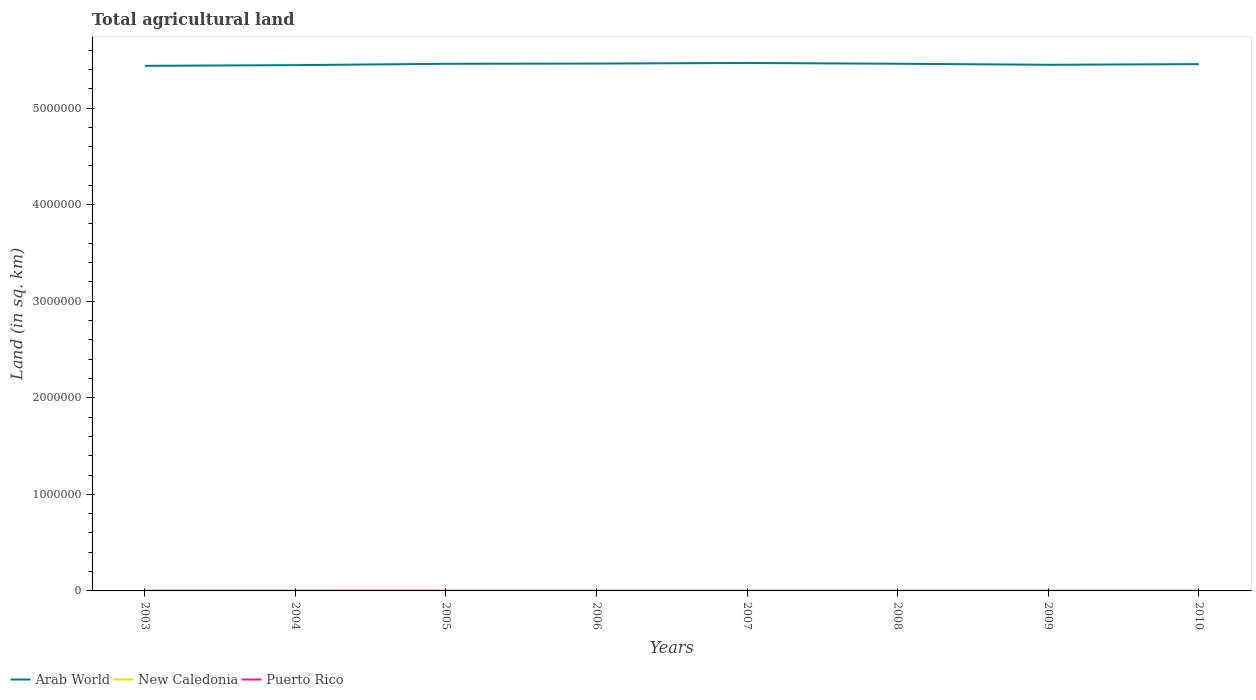Does the line corresponding to Puerto Rico intersect with the line corresponding to New Caledonia?
Ensure brevity in your answer.  No. Across all years, what is the maximum total agricultural land in Arab World?
Your response must be concise. 5.44e+06. What is the total total agricultural land in Puerto Rico in the graph?
Ensure brevity in your answer.  88. What is the difference between the highest and the second highest total agricultural land in Arab World?
Ensure brevity in your answer.  2.96e+04. What is the difference between the highest and the lowest total agricultural land in Arab World?
Keep it short and to the point. 5. Is the total agricultural land in Puerto Rico strictly greater than the total agricultural land in Arab World over the years?
Ensure brevity in your answer.  Yes. How many lines are there?
Offer a terse response. 3. How many years are there in the graph?
Ensure brevity in your answer.  8. Does the graph contain any zero values?
Make the answer very short. No. How are the legend labels stacked?
Keep it short and to the point. Horizontal. What is the title of the graph?
Your response must be concise. Total agricultural land. What is the label or title of the X-axis?
Ensure brevity in your answer.  Years. What is the label or title of the Y-axis?
Keep it short and to the point. Land (in sq. km). What is the Land (in sq. km) in Arab World in 2003?
Provide a succinct answer. 5.44e+06. What is the Land (in sq. km) of New Caledonia in 2003?
Make the answer very short. 2436. What is the Land (in sq. km) of Puerto Rico in 2003?
Make the answer very short. 2160. What is the Land (in sq. km) in Arab World in 2004?
Your response must be concise. 5.44e+06. What is the Land (in sq. km) in New Caledonia in 2004?
Keep it short and to the point. 2366. What is the Land (in sq. km) in Puerto Rico in 2004?
Provide a short and direct response. 2100. What is the Land (in sq. km) of Arab World in 2005?
Offer a very short reply. 5.46e+06. What is the Land (in sq. km) in New Caledonia in 2005?
Offer a terse response. 2301. What is the Land (in sq. km) of Puerto Rico in 2005?
Your answer should be compact. 2010. What is the Land (in sq. km) of Arab World in 2006?
Provide a short and direct response. 5.46e+06. What is the Land (in sq. km) in New Caledonia in 2006?
Ensure brevity in your answer.  2246. What is the Land (in sq. km) in Puerto Rico in 2006?
Offer a very short reply. 1949. What is the Land (in sq. km) of Arab World in 2007?
Give a very brief answer. 5.47e+06. What is the Land (in sq. km) of New Caledonia in 2007?
Make the answer very short. 2181. What is the Land (in sq. km) in Puerto Rico in 2007?
Offer a very short reply. 1890. What is the Land (in sq. km) in Arab World in 2008?
Your response must be concise. 5.46e+06. What is the Land (in sq. km) in New Caledonia in 2008?
Keep it short and to the point. 2106. What is the Land (in sq. km) in Puerto Rico in 2008?
Give a very brief answer. 1906. What is the Land (in sq. km) in Arab World in 2009?
Ensure brevity in your answer.  5.45e+06. What is the Land (in sq. km) in New Caledonia in 2009?
Your answer should be very brief. 2056. What is the Land (in sq. km) in Puerto Rico in 2009?
Your answer should be very brief. 1922. What is the Land (in sq. km) of Arab World in 2010?
Your answer should be very brief. 5.45e+06. What is the Land (in sq. km) in New Caledonia in 2010?
Keep it short and to the point. 1986. What is the Land (in sq. km) of Puerto Rico in 2010?
Make the answer very short. 1937. Across all years, what is the maximum Land (in sq. km) of Arab World?
Your answer should be very brief. 5.47e+06. Across all years, what is the maximum Land (in sq. km) in New Caledonia?
Ensure brevity in your answer.  2436. Across all years, what is the maximum Land (in sq. km) in Puerto Rico?
Give a very brief answer. 2160. Across all years, what is the minimum Land (in sq. km) of Arab World?
Make the answer very short. 5.44e+06. Across all years, what is the minimum Land (in sq. km) of New Caledonia?
Your answer should be compact. 1986. Across all years, what is the minimum Land (in sq. km) of Puerto Rico?
Provide a succinct answer. 1890. What is the total Land (in sq. km) of Arab World in the graph?
Give a very brief answer. 4.36e+07. What is the total Land (in sq. km) in New Caledonia in the graph?
Give a very brief answer. 1.77e+04. What is the total Land (in sq. km) of Puerto Rico in the graph?
Ensure brevity in your answer.  1.59e+04. What is the difference between the Land (in sq. km) in Arab World in 2003 and that in 2004?
Make the answer very short. -7274. What is the difference between the Land (in sq. km) in New Caledonia in 2003 and that in 2004?
Offer a terse response. 70. What is the difference between the Land (in sq. km) of Puerto Rico in 2003 and that in 2004?
Give a very brief answer. 60. What is the difference between the Land (in sq. km) of Arab World in 2003 and that in 2005?
Your response must be concise. -2.08e+04. What is the difference between the Land (in sq. km) of New Caledonia in 2003 and that in 2005?
Give a very brief answer. 135. What is the difference between the Land (in sq. km) of Puerto Rico in 2003 and that in 2005?
Your answer should be compact. 150. What is the difference between the Land (in sq. km) of Arab World in 2003 and that in 2006?
Ensure brevity in your answer.  -2.34e+04. What is the difference between the Land (in sq. km) of New Caledonia in 2003 and that in 2006?
Your answer should be compact. 190. What is the difference between the Land (in sq. km) in Puerto Rico in 2003 and that in 2006?
Provide a short and direct response. 211. What is the difference between the Land (in sq. km) of Arab World in 2003 and that in 2007?
Provide a succinct answer. -2.96e+04. What is the difference between the Land (in sq. km) of New Caledonia in 2003 and that in 2007?
Your answer should be compact. 255. What is the difference between the Land (in sq. km) in Puerto Rico in 2003 and that in 2007?
Your answer should be compact. 270. What is the difference between the Land (in sq. km) in Arab World in 2003 and that in 2008?
Provide a short and direct response. -2.14e+04. What is the difference between the Land (in sq. km) of New Caledonia in 2003 and that in 2008?
Give a very brief answer. 330. What is the difference between the Land (in sq. km) in Puerto Rico in 2003 and that in 2008?
Offer a very short reply. 254. What is the difference between the Land (in sq. km) of Arab World in 2003 and that in 2009?
Provide a succinct answer. -1.08e+04. What is the difference between the Land (in sq. km) in New Caledonia in 2003 and that in 2009?
Provide a succinct answer. 380. What is the difference between the Land (in sq. km) of Puerto Rico in 2003 and that in 2009?
Your answer should be very brief. 238. What is the difference between the Land (in sq. km) of Arab World in 2003 and that in 2010?
Ensure brevity in your answer.  -1.76e+04. What is the difference between the Land (in sq. km) in New Caledonia in 2003 and that in 2010?
Provide a succinct answer. 450. What is the difference between the Land (in sq. km) in Puerto Rico in 2003 and that in 2010?
Give a very brief answer. 223. What is the difference between the Land (in sq. km) of Arab World in 2004 and that in 2005?
Offer a very short reply. -1.35e+04. What is the difference between the Land (in sq. km) in Puerto Rico in 2004 and that in 2005?
Offer a very short reply. 90. What is the difference between the Land (in sq. km) in Arab World in 2004 and that in 2006?
Keep it short and to the point. -1.61e+04. What is the difference between the Land (in sq. km) of New Caledonia in 2004 and that in 2006?
Your answer should be very brief. 120. What is the difference between the Land (in sq. km) of Puerto Rico in 2004 and that in 2006?
Give a very brief answer. 151. What is the difference between the Land (in sq. km) of Arab World in 2004 and that in 2007?
Your answer should be very brief. -2.23e+04. What is the difference between the Land (in sq. km) of New Caledonia in 2004 and that in 2007?
Make the answer very short. 185. What is the difference between the Land (in sq. km) of Puerto Rico in 2004 and that in 2007?
Offer a very short reply. 210. What is the difference between the Land (in sq. km) in Arab World in 2004 and that in 2008?
Your answer should be compact. -1.41e+04. What is the difference between the Land (in sq. km) of New Caledonia in 2004 and that in 2008?
Offer a terse response. 260. What is the difference between the Land (in sq. km) in Puerto Rico in 2004 and that in 2008?
Give a very brief answer. 194. What is the difference between the Land (in sq. km) of Arab World in 2004 and that in 2009?
Offer a terse response. -3524.6. What is the difference between the Land (in sq. km) of New Caledonia in 2004 and that in 2009?
Keep it short and to the point. 310. What is the difference between the Land (in sq. km) in Puerto Rico in 2004 and that in 2009?
Your answer should be very brief. 178. What is the difference between the Land (in sq. km) in Arab World in 2004 and that in 2010?
Offer a terse response. -1.03e+04. What is the difference between the Land (in sq. km) of New Caledonia in 2004 and that in 2010?
Provide a succinct answer. 380. What is the difference between the Land (in sq. km) in Puerto Rico in 2004 and that in 2010?
Give a very brief answer. 163. What is the difference between the Land (in sq. km) of Arab World in 2005 and that in 2006?
Give a very brief answer. -2590.5. What is the difference between the Land (in sq. km) in Arab World in 2005 and that in 2007?
Your answer should be compact. -8773. What is the difference between the Land (in sq. km) in New Caledonia in 2005 and that in 2007?
Provide a short and direct response. 120. What is the difference between the Land (in sq. km) in Puerto Rico in 2005 and that in 2007?
Offer a very short reply. 120. What is the difference between the Land (in sq. km) in Arab World in 2005 and that in 2008?
Make the answer very short. -601.8. What is the difference between the Land (in sq. km) in New Caledonia in 2005 and that in 2008?
Keep it short and to the point. 195. What is the difference between the Land (in sq. km) of Puerto Rico in 2005 and that in 2008?
Provide a succinct answer. 104. What is the difference between the Land (in sq. km) of Arab World in 2005 and that in 2009?
Keep it short and to the point. 1.00e+04. What is the difference between the Land (in sq. km) of New Caledonia in 2005 and that in 2009?
Provide a short and direct response. 245. What is the difference between the Land (in sq. km) of Arab World in 2005 and that in 2010?
Your response must be concise. 3201. What is the difference between the Land (in sq. km) of New Caledonia in 2005 and that in 2010?
Keep it short and to the point. 315. What is the difference between the Land (in sq. km) in Arab World in 2006 and that in 2007?
Your response must be concise. -6182.5. What is the difference between the Land (in sq. km) of Puerto Rico in 2006 and that in 2007?
Ensure brevity in your answer.  59. What is the difference between the Land (in sq. km) in Arab World in 2006 and that in 2008?
Your response must be concise. 1988.7. What is the difference between the Land (in sq. km) in New Caledonia in 2006 and that in 2008?
Provide a succinct answer. 140. What is the difference between the Land (in sq. km) in Arab World in 2006 and that in 2009?
Make the answer very short. 1.26e+04. What is the difference between the Land (in sq. km) of New Caledonia in 2006 and that in 2009?
Give a very brief answer. 190. What is the difference between the Land (in sq. km) of Puerto Rico in 2006 and that in 2009?
Offer a very short reply. 27. What is the difference between the Land (in sq. km) of Arab World in 2006 and that in 2010?
Keep it short and to the point. 5791.5. What is the difference between the Land (in sq. km) of New Caledonia in 2006 and that in 2010?
Provide a short and direct response. 260. What is the difference between the Land (in sq. km) of Arab World in 2007 and that in 2008?
Make the answer very short. 8171.2. What is the difference between the Land (in sq. km) of New Caledonia in 2007 and that in 2008?
Offer a very short reply. 75. What is the difference between the Land (in sq. km) of Puerto Rico in 2007 and that in 2008?
Ensure brevity in your answer.  -16. What is the difference between the Land (in sq. km) of Arab World in 2007 and that in 2009?
Offer a terse response. 1.88e+04. What is the difference between the Land (in sq. km) in New Caledonia in 2007 and that in 2009?
Ensure brevity in your answer.  125. What is the difference between the Land (in sq. km) of Puerto Rico in 2007 and that in 2009?
Offer a terse response. -32. What is the difference between the Land (in sq. km) of Arab World in 2007 and that in 2010?
Give a very brief answer. 1.20e+04. What is the difference between the Land (in sq. km) in New Caledonia in 2007 and that in 2010?
Keep it short and to the point. 195. What is the difference between the Land (in sq. km) of Puerto Rico in 2007 and that in 2010?
Your response must be concise. -47. What is the difference between the Land (in sq. km) of Arab World in 2008 and that in 2009?
Keep it short and to the point. 1.06e+04. What is the difference between the Land (in sq. km) in New Caledonia in 2008 and that in 2009?
Offer a terse response. 50. What is the difference between the Land (in sq. km) of Arab World in 2008 and that in 2010?
Provide a succinct answer. 3802.8. What is the difference between the Land (in sq. km) in New Caledonia in 2008 and that in 2010?
Provide a succinct answer. 120. What is the difference between the Land (in sq. km) of Puerto Rico in 2008 and that in 2010?
Your answer should be compact. -31. What is the difference between the Land (in sq. km) of Arab World in 2009 and that in 2010?
Provide a succinct answer. -6815.4. What is the difference between the Land (in sq. km) of Puerto Rico in 2009 and that in 2010?
Provide a short and direct response. -15. What is the difference between the Land (in sq. km) in Arab World in 2003 and the Land (in sq. km) in New Caledonia in 2004?
Your answer should be compact. 5.43e+06. What is the difference between the Land (in sq. km) in Arab World in 2003 and the Land (in sq. km) in Puerto Rico in 2004?
Provide a succinct answer. 5.43e+06. What is the difference between the Land (in sq. km) of New Caledonia in 2003 and the Land (in sq. km) of Puerto Rico in 2004?
Offer a terse response. 336. What is the difference between the Land (in sq. km) of Arab World in 2003 and the Land (in sq. km) of New Caledonia in 2005?
Keep it short and to the point. 5.43e+06. What is the difference between the Land (in sq. km) of Arab World in 2003 and the Land (in sq. km) of Puerto Rico in 2005?
Keep it short and to the point. 5.43e+06. What is the difference between the Land (in sq. km) in New Caledonia in 2003 and the Land (in sq. km) in Puerto Rico in 2005?
Provide a succinct answer. 426. What is the difference between the Land (in sq. km) in Arab World in 2003 and the Land (in sq. km) in New Caledonia in 2006?
Offer a very short reply. 5.43e+06. What is the difference between the Land (in sq. km) of Arab World in 2003 and the Land (in sq. km) of Puerto Rico in 2006?
Your answer should be compact. 5.43e+06. What is the difference between the Land (in sq. km) in New Caledonia in 2003 and the Land (in sq. km) in Puerto Rico in 2006?
Offer a very short reply. 487. What is the difference between the Land (in sq. km) of Arab World in 2003 and the Land (in sq. km) of New Caledonia in 2007?
Provide a short and direct response. 5.43e+06. What is the difference between the Land (in sq. km) in Arab World in 2003 and the Land (in sq. km) in Puerto Rico in 2007?
Provide a short and direct response. 5.43e+06. What is the difference between the Land (in sq. km) in New Caledonia in 2003 and the Land (in sq. km) in Puerto Rico in 2007?
Your answer should be very brief. 546. What is the difference between the Land (in sq. km) of Arab World in 2003 and the Land (in sq. km) of New Caledonia in 2008?
Provide a short and direct response. 5.43e+06. What is the difference between the Land (in sq. km) of Arab World in 2003 and the Land (in sq. km) of Puerto Rico in 2008?
Your answer should be very brief. 5.43e+06. What is the difference between the Land (in sq. km) in New Caledonia in 2003 and the Land (in sq. km) in Puerto Rico in 2008?
Provide a succinct answer. 530. What is the difference between the Land (in sq. km) of Arab World in 2003 and the Land (in sq. km) of New Caledonia in 2009?
Your answer should be compact. 5.43e+06. What is the difference between the Land (in sq. km) in Arab World in 2003 and the Land (in sq. km) in Puerto Rico in 2009?
Your answer should be very brief. 5.43e+06. What is the difference between the Land (in sq. km) of New Caledonia in 2003 and the Land (in sq. km) of Puerto Rico in 2009?
Provide a short and direct response. 514. What is the difference between the Land (in sq. km) in Arab World in 2003 and the Land (in sq. km) in New Caledonia in 2010?
Give a very brief answer. 5.43e+06. What is the difference between the Land (in sq. km) in Arab World in 2003 and the Land (in sq. km) in Puerto Rico in 2010?
Make the answer very short. 5.43e+06. What is the difference between the Land (in sq. km) in New Caledonia in 2003 and the Land (in sq. km) in Puerto Rico in 2010?
Make the answer very short. 499. What is the difference between the Land (in sq. km) in Arab World in 2004 and the Land (in sq. km) in New Caledonia in 2005?
Make the answer very short. 5.44e+06. What is the difference between the Land (in sq. km) of Arab World in 2004 and the Land (in sq. km) of Puerto Rico in 2005?
Make the answer very short. 5.44e+06. What is the difference between the Land (in sq. km) of New Caledonia in 2004 and the Land (in sq. km) of Puerto Rico in 2005?
Provide a succinct answer. 356. What is the difference between the Land (in sq. km) of Arab World in 2004 and the Land (in sq. km) of New Caledonia in 2006?
Your answer should be very brief. 5.44e+06. What is the difference between the Land (in sq. km) of Arab World in 2004 and the Land (in sq. km) of Puerto Rico in 2006?
Your answer should be very brief. 5.44e+06. What is the difference between the Land (in sq. km) of New Caledonia in 2004 and the Land (in sq. km) of Puerto Rico in 2006?
Your answer should be compact. 417. What is the difference between the Land (in sq. km) in Arab World in 2004 and the Land (in sq. km) in New Caledonia in 2007?
Ensure brevity in your answer.  5.44e+06. What is the difference between the Land (in sq. km) in Arab World in 2004 and the Land (in sq. km) in Puerto Rico in 2007?
Offer a very short reply. 5.44e+06. What is the difference between the Land (in sq. km) of New Caledonia in 2004 and the Land (in sq. km) of Puerto Rico in 2007?
Make the answer very short. 476. What is the difference between the Land (in sq. km) in Arab World in 2004 and the Land (in sq. km) in New Caledonia in 2008?
Ensure brevity in your answer.  5.44e+06. What is the difference between the Land (in sq. km) in Arab World in 2004 and the Land (in sq. km) in Puerto Rico in 2008?
Make the answer very short. 5.44e+06. What is the difference between the Land (in sq. km) of New Caledonia in 2004 and the Land (in sq. km) of Puerto Rico in 2008?
Ensure brevity in your answer.  460. What is the difference between the Land (in sq. km) of Arab World in 2004 and the Land (in sq. km) of New Caledonia in 2009?
Your response must be concise. 5.44e+06. What is the difference between the Land (in sq. km) of Arab World in 2004 and the Land (in sq. km) of Puerto Rico in 2009?
Your answer should be very brief. 5.44e+06. What is the difference between the Land (in sq. km) in New Caledonia in 2004 and the Land (in sq. km) in Puerto Rico in 2009?
Provide a short and direct response. 444. What is the difference between the Land (in sq. km) in Arab World in 2004 and the Land (in sq. km) in New Caledonia in 2010?
Ensure brevity in your answer.  5.44e+06. What is the difference between the Land (in sq. km) in Arab World in 2004 and the Land (in sq. km) in Puerto Rico in 2010?
Give a very brief answer. 5.44e+06. What is the difference between the Land (in sq. km) in New Caledonia in 2004 and the Land (in sq. km) in Puerto Rico in 2010?
Make the answer very short. 429. What is the difference between the Land (in sq. km) of Arab World in 2005 and the Land (in sq. km) of New Caledonia in 2006?
Give a very brief answer. 5.46e+06. What is the difference between the Land (in sq. km) in Arab World in 2005 and the Land (in sq. km) in Puerto Rico in 2006?
Keep it short and to the point. 5.46e+06. What is the difference between the Land (in sq. km) of New Caledonia in 2005 and the Land (in sq. km) of Puerto Rico in 2006?
Keep it short and to the point. 352. What is the difference between the Land (in sq. km) in Arab World in 2005 and the Land (in sq. km) in New Caledonia in 2007?
Offer a terse response. 5.46e+06. What is the difference between the Land (in sq. km) of Arab World in 2005 and the Land (in sq. km) of Puerto Rico in 2007?
Provide a short and direct response. 5.46e+06. What is the difference between the Land (in sq. km) of New Caledonia in 2005 and the Land (in sq. km) of Puerto Rico in 2007?
Offer a terse response. 411. What is the difference between the Land (in sq. km) in Arab World in 2005 and the Land (in sq. km) in New Caledonia in 2008?
Make the answer very short. 5.46e+06. What is the difference between the Land (in sq. km) in Arab World in 2005 and the Land (in sq. km) in Puerto Rico in 2008?
Your response must be concise. 5.46e+06. What is the difference between the Land (in sq. km) of New Caledonia in 2005 and the Land (in sq. km) of Puerto Rico in 2008?
Make the answer very short. 395. What is the difference between the Land (in sq. km) in Arab World in 2005 and the Land (in sq. km) in New Caledonia in 2009?
Offer a terse response. 5.46e+06. What is the difference between the Land (in sq. km) of Arab World in 2005 and the Land (in sq. km) of Puerto Rico in 2009?
Give a very brief answer. 5.46e+06. What is the difference between the Land (in sq. km) of New Caledonia in 2005 and the Land (in sq. km) of Puerto Rico in 2009?
Keep it short and to the point. 379. What is the difference between the Land (in sq. km) in Arab World in 2005 and the Land (in sq. km) in New Caledonia in 2010?
Provide a short and direct response. 5.46e+06. What is the difference between the Land (in sq. km) of Arab World in 2005 and the Land (in sq. km) of Puerto Rico in 2010?
Offer a terse response. 5.46e+06. What is the difference between the Land (in sq. km) of New Caledonia in 2005 and the Land (in sq. km) of Puerto Rico in 2010?
Keep it short and to the point. 364. What is the difference between the Land (in sq. km) of Arab World in 2006 and the Land (in sq. km) of New Caledonia in 2007?
Make the answer very short. 5.46e+06. What is the difference between the Land (in sq. km) of Arab World in 2006 and the Land (in sq. km) of Puerto Rico in 2007?
Make the answer very short. 5.46e+06. What is the difference between the Land (in sq. km) of New Caledonia in 2006 and the Land (in sq. km) of Puerto Rico in 2007?
Provide a short and direct response. 356. What is the difference between the Land (in sq. km) of Arab World in 2006 and the Land (in sq. km) of New Caledonia in 2008?
Your response must be concise. 5.46e+06. What is the difference between the Land (in sq. km) of Arab World in 2006 and the Land (in sq. km) of Puerto Rico in 2008?
Give a very brief answer. 5.46e+06. What is the difference between the Land (in sq. km) in New Caledonia in 2006 and the Land (in sq. km) in Puerto Rico in 2008?
Make the answer very short. 340. What is the difference between the Land (in sq. km) in Arab World in 2006 and the Land (in sq. km) in New Caledonia in 2009?
Provide a succinct answer. 5.46e+06. What is the difference between the Land (in sq. km) in Arab World in 2006 and the Land (in sq. km) in Puerto Rico in 2009?
Your response must be concise. 5.46e+06. What is the difference between the Land (in sq. km) of New Caledonia in 2006 and the Land (in sq. km) of Puerto Rico in 2009?
Offer a terse response. 324. What is the difference between the Land (in sq. km) in Arab World in 2006 and the Land (in sq. km) in New Caledonia in 2010?
Ensure brevity in your answer.  5.46e+06. What is the difference between the Land (in sq. km) of Arab World in 2006 and the Land (in sq. km) of Puerto Rico in 2010?
Your answer should be compact. 5.46e+06. What is the difference between the Land (in sq. km) in New Caledonia in 2006 and the Land (in sq. km) in Puerto Rico in 2010?
Your answer should be very brief. 309. What is the difference between the Land (in sq. km) in Arab World in 2007 and the Land (in sq. km) in New Caledonia in 2008?
Offer a terse response. 5.46e+06. What is the difference between the Land (in sq. km) in Arab World in 2007 and the Land (in sq. km) in Puerto Rico in 2008?
Provide a succinct answer. 5.46e+06. What is the difference between the Land (in sq. km) in New Caledonia in 2007 and the Land (in sq. km) in Puerto Rico in 2008?
Your answer should be very brief. 275. What is the difference between the Land (in sq. km) of Arab World in 2007 and the Land (in sq. km) of New Caledonia in 2009?
Give a very brief answer. 5.46e+06. What is the difference between the Land (in sq. km) in Arab World in 2007 and the Land (in sq. km) in Puerto Rico in 2009?
Give a very brief answer. 5.46e+06. What is the difference between the Land (in sq. km) of New Caledonia in 2007 and the Land (in sq. km) of Puerto Rico in 2009?
Offer a very short reply. 259. What is the difference between the Land (in sq. km) of Arab World in 2007 and the Land (in sq. km) of New Caledonia in 2010?
Ensure brevity in your answer.  5.46e+06. What is the difference between the Land (in sq. km) of Arab World in 2007 and the Land (in sq. km) of Puerto Rico in 2010?
Your response must be concise. 5.46e+06. What is the difference between the Land (in sq. km) in New Caledonia in 2007 and the Land (in sq. km) in Puerto Rico in 2010?
Provide a short and direct response. 244. What is the difference between the Land (in sq. km) of Arab World in 2008 and the Land (in sq. km) of New Caledonia in 2009?
Ensure brevity in your answer.  5.46e+06. What is the difference between the Land (in sq. km) in Arab World in 2008 and the Land (in sq. km) in Puerto Rico in 2009?
Make the answer very short. 5.46e+06. What is the difference between the Land (in sq. km) in New Caledonia in 2008 and the Land (in sq. km) in Puerto Rico in 2009?
Give a very brief answer. 184. What is the difference between the Land (in sq. km) in Arab World in 2008 and the Land (in sq. km) in New Caledonia in 2010?
Ensure brevity in your answer.  5.46e+06. What is the difference between the Land (in sq. km) of Arab World in 2008 and the Land (in sq. km) of Puerto Rico in 2010?
Give a very brief answer. 5.46e+06. What is the difference between the Land (in sq. km) in New Caledonia in 2008 and the Land (in sq. km) in Puerto Rico in 2010?
Keep it short and to the point. 169. What is the difference between the Land (in sq. km) in Arab World in 2009 and the Land (in sq. km) in New Caledonia in 2010?
Provide a short and direct response. 5.45e+06. What is the difference between the Land (in sq. km) of Arab World in 2009 and the Land (in sq. km) of Puerto Rico in 2010?
Keep it short and to the point. 5.45e+06. What is the difference between the Land (in sq. km) of New Caledonia in 2009 and the Land (in sq. km) of Puerto Rico in 2010?
Ensure brevity in your answer.  119. What is the average Land (in sq. km) in Arab World per year?
Your answer should be very brief. 5.45e+06. What is the average Land (in sq. km) of New Caledonia per year?
Your answer should be compact. 2209.75. What is the average Land (in sq. km) of Puerto Rico per year?
Your response must be concise. 1984.25. In the year 2003, what is the difference between the Land (in sq. km) of Arab World and Land (in sq. km) of New Caledonia?
Your answer should be very brief. 5.43e+06. In the year 2003, what is the difference between the Land (in sq. km) of Arab World and Land (in sq. km) of Puerto Rico?
Ensure brevity in your answer.  5.43e+06. In the year 2003, what is the difference between the Land (in sq. km) in New Caledonia and Land (in sq. km) in Puerto Rico?
Keep it short and to the point. 276. In the year 2004, what is the difference between the Land (in sq. km) in Arab World and Land (in sq. km) in New Caledonia?
Your answer should be compact. 5.44e+06. In the year 2004, what is the difference between the Land (in sq. km) in Arab World and Land (in sq. km) in Puerto Rico?
Your answer should be compact. 5.44e+06. In the year 2004, what is the difference between the Land (in sq. km) of New Caledonia and Land (in sq. km) of Puerto Rico?
Give a very brief answer. 266. In the year 2005, what is the difference between the Land (in sq. km) in Arab World and Land (in sq. km) in New Caledonia?
Offer a terse response. 5.46e+06. In the year 2005, what is the difference between the Land (in sq. km) in Arab World and Land (in sq. km) in Puerto Rico?
Make the answer very short. 5.46e+06. In the year 2005, what is the difference between the Land (in sq. km) in New Caledonia and Land (in sq. km) in Puerto Rico?
Keep it short and to the point. 291. In the year 2006, what is the difference between the Land (in sq. km) of Arab World and Land (in sq. km) of New Caledonia?
Keep it short and to the point. 5.46e+06. In the year 2006, what is the difference between the Land (in sq. km) in Arab World and Land (in sq. km) in Puerto Rico?
Provide a short and direct response. 5.46e+06. In the year 2006, what is the difference between the Land (in sq. km) in New Caledonia and Land (in sq. km) in Puerto Rico?
Provide a succinct answer. 297. In the year 2007, what is the difference between the Land (in sq. km) of Arab World and Land (in sq. km) of New Caledonia?
Offer a terse response. 5.46e+06. In the year 2007, what is the difference between the Land (in sq. km) in Arab World and Land (in sq. km) in Puerto Rico?
Your response must be concise. 5.46e+06. In the year 2007, what is the difference between the Land (in sq. km) in New Caledonia and Land (in sq. km) in Puerto Rico?
Your answer should be compact. 291. In the year 2008, what is the difference between the Land (in sq. km) of Arab World and Land (in sq. km) of New Caledonia?
Give a very brief answer. 5.46e+06. In the year 2008, what is the difference between the Land (in sq. km) in Arab World and Land (in sq. km) in Puerto Rico?
Make the answer very short. 5.46e+06. In the year 2008, what is the difference between the Land (in sq. km) of New Caledonia and Land (in sq. km) of Puerto Rico?
Provide a short and direct response. 200. In the year 2009, what is the difference between the Land (in sq. km) in Arab World and Land (in sq. km) in New Caledonia?
Provide a succinct answer. 5.45e+06. In the year 2009, what is the difference between the Land (in sq. km) of Arab World and Land (in sq. km) of Puerto Rico?
Your answer should be compact. 5.45e+06. In the year 2009, what is the difference between the Land (in sq. km) in New Caledonia and Land (in sq. km) in Puerto Rico?
Ensure brevity in your answer.  134. In the year 2010, what is the difference between the Land (in sq. km) of Arab World and Land (in sq. km) of New Caledonia?
Provide a short and direct response. 5.45e+06. In the year 2010, what is the difference between the Land (in sq. km) of Arab World and Land (in sq. km) of Puerto Rico?
Provide a short and direct response. 5.45e+06. What is the ratio of the Land (in sq. km) of New Caledonia in 2003 to that in 2004?
Give a very brief answer. 1.03. What is the ratio of the Land (in sq. km) of Puerto Rico in 2003 to that in 2004?
Your answer should be very brief. 1.03. What is the ratio of the Land (in sq. km) of New Caledonia in 2003 to that in 2005?
Offer a very short reply. 1.06. What is the ratio of the Land (in sq. km) of Puerto Rico in 2003 to that in 2005?
Your answer should be very brief. 1.07. What is the ratio of the Land (in sq. km) of New Caledonia in 2003 to that in 2006?
Your response must be concise. 1.08. What is the ratio of the Land (in sq. km) of Puerto Rico in 2003 to that in 2006?
Provide a succinct answer. 1.11. What is the ratio of the Land (in sq. km) of Arab World in 2003 to that in 2007?
Keep it short and to the point. 0.99. What is the ratio of the Land (in sq. km) in New Caledonia in 2003 to that in 2007?
Provide a succinct answer. 1.12. What is the ratio of the Land (in sq. km) of New Caledonia in 2003 to that in 2008?
Provide a short and direct response. 1.16. What is the ratio of the Land (in sq. km) of Puerto Rico in 2003 to that in 2008?
Offer a very short reply. 1.13. What is the ratio of the Land (in sq. km) of New Caledonia in 2003 to that in 2009?
Make the answer very short. 1.18. What is the ratio of the Land (in sq. km) of Puerto Rico in 2003 to that in 2009?
Provide a succinct answer. 1.12. What is the ratio of the Land (in sq. km) of Arab World in 2003 to that in 2010?
Ensure brevity in your answer.  1. What is the ratio of the Land (in sq. km) in New Caledonia in 2003 to that in 2010?
Your response must be concise. 1.23. What is the ratio of the Land (in sq. km) in Puerto Rico in 2003 to that in 2010?
Make the answer very short. 1.12. What is the ratio of the Land (in sq. km) in Arab World in 2004 to that in 2005?
Provide a short and direct response. 1. What is the ratio of the Land (in sq. km) of New Caledonia in 2004 to that in 2005?
Make the answer very short. 1.03. What is the ratio of the Land (in sq. km) of Puerto Rico in 2004 to that in 2005?
Keep it short and to the point. 1.04. What is the ratio of the Land (in sq. km) in Arab World in 2004 to that in 2006?
Give a very brief answer. 1. What is the ratio of the Land (in sq. km) of New Caledonia in 2004 to that in 2006?
Provide a short and direct response. 1.05. What is the ratio of the Land (in sq. km) in Puerto Rico in 2004 to that in 2006?
Your answer should be compact. 1.08. What is the ratio of the Land (in sq. km) in New Caledonia in 2004 to that in 2007?
Provide a short and direct response. 1.08. What is the ratio of the Land (in sq. km) of New Caledonia in 2004 to that in 2008?
Your response must be concise. 1.12. What is the ratio of the Land (in sq. km) in Puerto Rico in 2004 to that in 2008?
Your response must be concise. 1.1. What is the ratio of the Land (in sq. km) in Arab World in 2004 to that in 2009?
Offer a very short reply. 1. What is the ratio of the Land (in sq. km) of New Caledonia in 2004 to that in 2009?
Ensure brevity in your answer.  1.15. What is the ratio of the Land (in sq. km) of Puerto Rico in 2004 to that in 2009?
Provide a short and direct response. 1.09. What is the ratio of the Land (in sq. km) of New Caledonia in 2004 to that in 2010?
Keep it short and to the point. 1.19. What is the ratio of the Land (in sq. km) of Puerto Rico in 2004 to that in 2010?
Make the answer very short. 1.08. What is the ratio of the Land (in sq. km) in New Caledonia in 2005 to that in 2006?
Your answer should be very brief. 1.02. What is the ratio of the Land (in sq. km) of Puerto Rico in 2005 to that in 2006?
Your answer should be compact. 1.03. What is the ratio of the Land (in sq. km) in New Caledonia in 2005 to that in 2007?
Give a very brief answer. 1.05. What is the ratio of the Land (in sq. km) of Puerto Rico in 2005 to that in 2007?
Give a very brief answer. 1.06. What is the ratio of the Land (in sq. km) of New Caledonia in 2005 to that in 2008?
Give a very brief answer. 1.09. What is the ratio of the Land (in sq. km) of Puerto Rico in 2005 to that in 2008?
Give a very brief answer. 1.05. What is the ratio of the Land (in sq. km) of New Caledonia in 2005 to that in 2009?
Give a very brief answer. 1.12. What is the ratio of the Land (in sq. km) of Puerto Rico in 2005 to that in 2009?
Your answer should be compact. 1.05. What is the ratio of the Land (in sq. km) in New Caledonia in 2005 to that in 2010?
Your answer should be compact. 1.16. What is the ratio of the Land (in sq. km) in Puerto Rico in 2005 to that in 2010?
Your answer should be compact. 1.04. What is the ratio of the Land (in sq. km) of Arab World in 2006 to that in 2007?
Ensure brevity in your answer.  1. What is the ratio of the Land (in sq. km) in New Caledonia in 2006 to that in 2007?
Offer a very short reply. 1.03. What is the ratio of the Land (in sq. km) of Puerto Rico in 2006 to that in 2007?
Your answer should be compact. 1.03. What is the ratio of the Land (in sq. km) in New Caledonia in 2006 to that in 2008?
Keep it short and to the point. 1.07. What is the ratio of the Land (in sq. km) in Puerto Rico in 2006 to that in 2008?
Offer a very short reply. 1.02. What is the ratio of the Land (in sq. km) in Arab World in 2006 to that in 2009?
Your response must be concise. 1. What is the ratio of the Land (in sq. km) of New Caledonia in 2006 to that in 2009?
Your answer should be compact. 1.09. What is the ratio of the Land (in sq. km) in Arab World in 2006 to that in 2010?
Offer a very short reply. 1. What is the ratio of the Land (in sq. km) of New Caledonia in 2006 to that in 2010?
Provide a succinct answer. 1.13. What is the ratio of the Land (in sq. km) of Arab World in 2007 to that in 2008?
Make the answer very short. 1. What is the ratio of the Land (in sq. km) in New Caledonia in 2007 to that in 2008?
Ensure brevity in your answer.  1.04. What is the ratio of the Land (in sq. km) of Arab World in 2007 to that in 2009?
Your answer should be compact. 1. What is the ratio of the Land (in sq. km) of New Caledonia in 2007 to that in 2009?
Provide a succinct answer. 1.06. What is the ratio of the Land (in sq. km) of Puerto Rico in 2007 to that in 2009?
Offer a terse response. 0.98. What is the ratio of the Land (in sq. km) of Arab World in 2007 to that in 2010?
Your answer should be very brief. 1. What is the ratio of the Land (in sq. km) of New Caledonia in 2007 to that in 2010?
Provide a succinct answer. 1.1. What is the ratio of the Land (in sq. km) of Puerto Rico in 2007 to that in 2010?
Your answer should be compact. 0.98. What is the ratio of the Land (in sq. km) in New Caledonia in 2008 to that in 2009?
Your answer should be very brief. 1.02. What is the ratio of the Land (in sq. km) of Puerto Rico in 2008 to that in 2009?
Offer a very short reply. 0.99. What is the ratio of the Land (in sq. km) of New Caledonia in 2008 to that in 2010?
Your response must be concise. 1.06. What is the ratio of the Land (in sq. km) in New Caledonia in 2009 to that in 2010?
Provide a succinct answer. 1.04. What is the difference between the highest and the second highest Land (in sq. km) of Arab World?
Offer a very short reply. 6182.5. What is the difference between the highest and the second highest Land (in sq. km) in New Caledonia?
Offer a very short reply. 70. What is the difference between the highest and the second highest Land (in sq. km) of Puerto Rico?
Provide a succinct answer. 60. What is the difference between the highest and the lowest Land (in sq. km) of Arab World?
Your response must be concise. 2.96e+04. What is the difference between the highest and the lowest Land (in sq. km) in New Caledonia?
Keep it short and to the point. 450. What is the difference between the highest and the lowest Land (in sq. km) in Puerto Rico?
Your response must be concise. 270. 